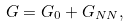<formula> <loc_0><loc_0><loc_500><loc_500>G = G _ { 0 } + G _ { N N } ,</formula> 